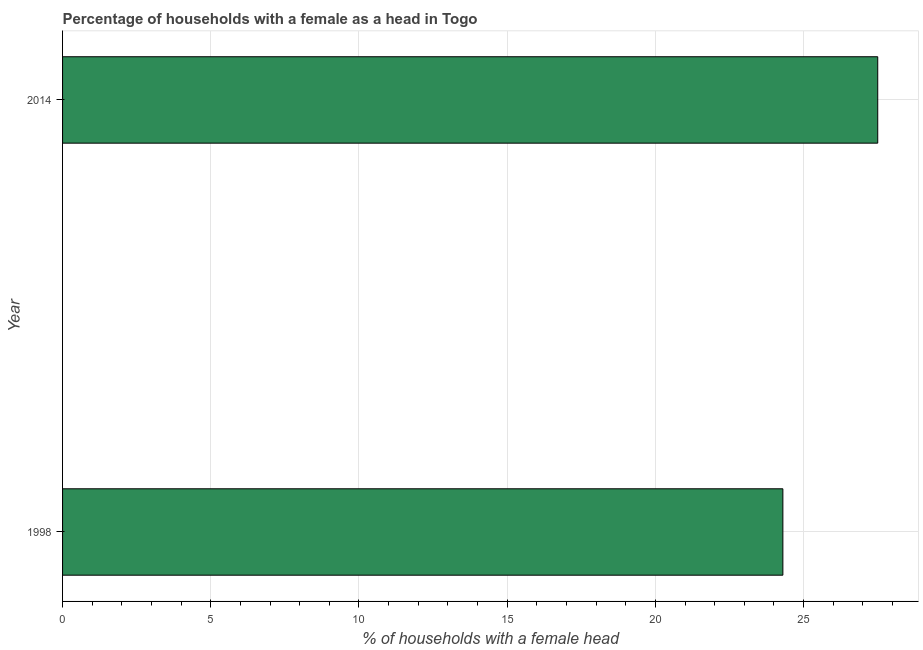Does the graph contain any zero values?
Your answer should be very brief. No. Does the graph contain grids?
Provide a succinct answer. Yes. What is the title of the graph?
Make the answer very short. Percentage of households with a female as a head in Togo. What is the label or title of the X-axis?
Make the answer very short. % of households with a female head. What is the number of female supervised households in 2014?
Keep it short and to the point. 27.5. Across all years, what is the maximum number of female supervised households?
Your answer should be compact. 27.5. Across all years, what is the minimum number of female supervised households?
Ensure brevity in your answer.  24.3. In which year was the number of female supervised households maximum?
Offer a very short reply. 2014. In which year was the number of female supervised households minimum?
Your answer should be compact. 1998. What is the sum of the number of female supervised households?
Give a very brief answer. 51.8. What is the average number of female supervised households per year?
Keep it short and to the point. 25.9. What is the median number of female supervised households?
Offer a terse response. 25.9. What is the ratio of the number of female supervised households in 1998 to that in 2014?
Keep it short and to the point. 0.88. In how many years, is the number of female supervised households greater than the average number of female supervised households taken over all years?
Offer a very short reply. 1. How many bars are there?
Your answer should be very brief. 2. Are all the bars in the graph horizontal?
Provide a short and direct response. Yes. How many years are there in the graph?
Offer a very short reply. 2. What is the % of households with a female head of 1998?
Your answer should be very brief. 24.3. What is the % of households with a female head in 2014?
Keep it short and to the point. 27.5. What is the difference between the % of households with a female head in 1998 and 2014?
Ensure brevity in your answer.  -3.2. What is the ratio of the % of households with a female head in 1998 to that in 2014?
Ensure brevity in your answer.  0.88. 